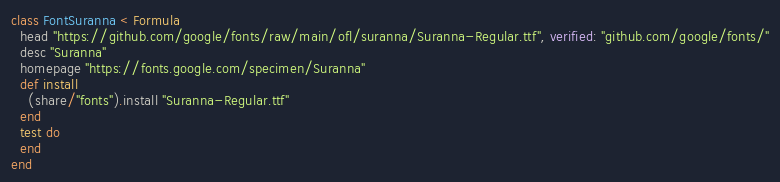<code> <loc_0><loc_0><loc_500><loc_500><_Ruby_>class FontSuranna < Formula
  head "https://github.com/google/fonts/raw/main/ofl/suranna/Suranna-Regular.ttf", verified: "github.com/google/fonts/"
  desc "Suranna"
  homepage "https://fonts.google.com/specimen/Suranna"
  def install
    (share/"fonts").install "Suranna-Regular.ttf"
  end
  test do
  end
end
</code> 